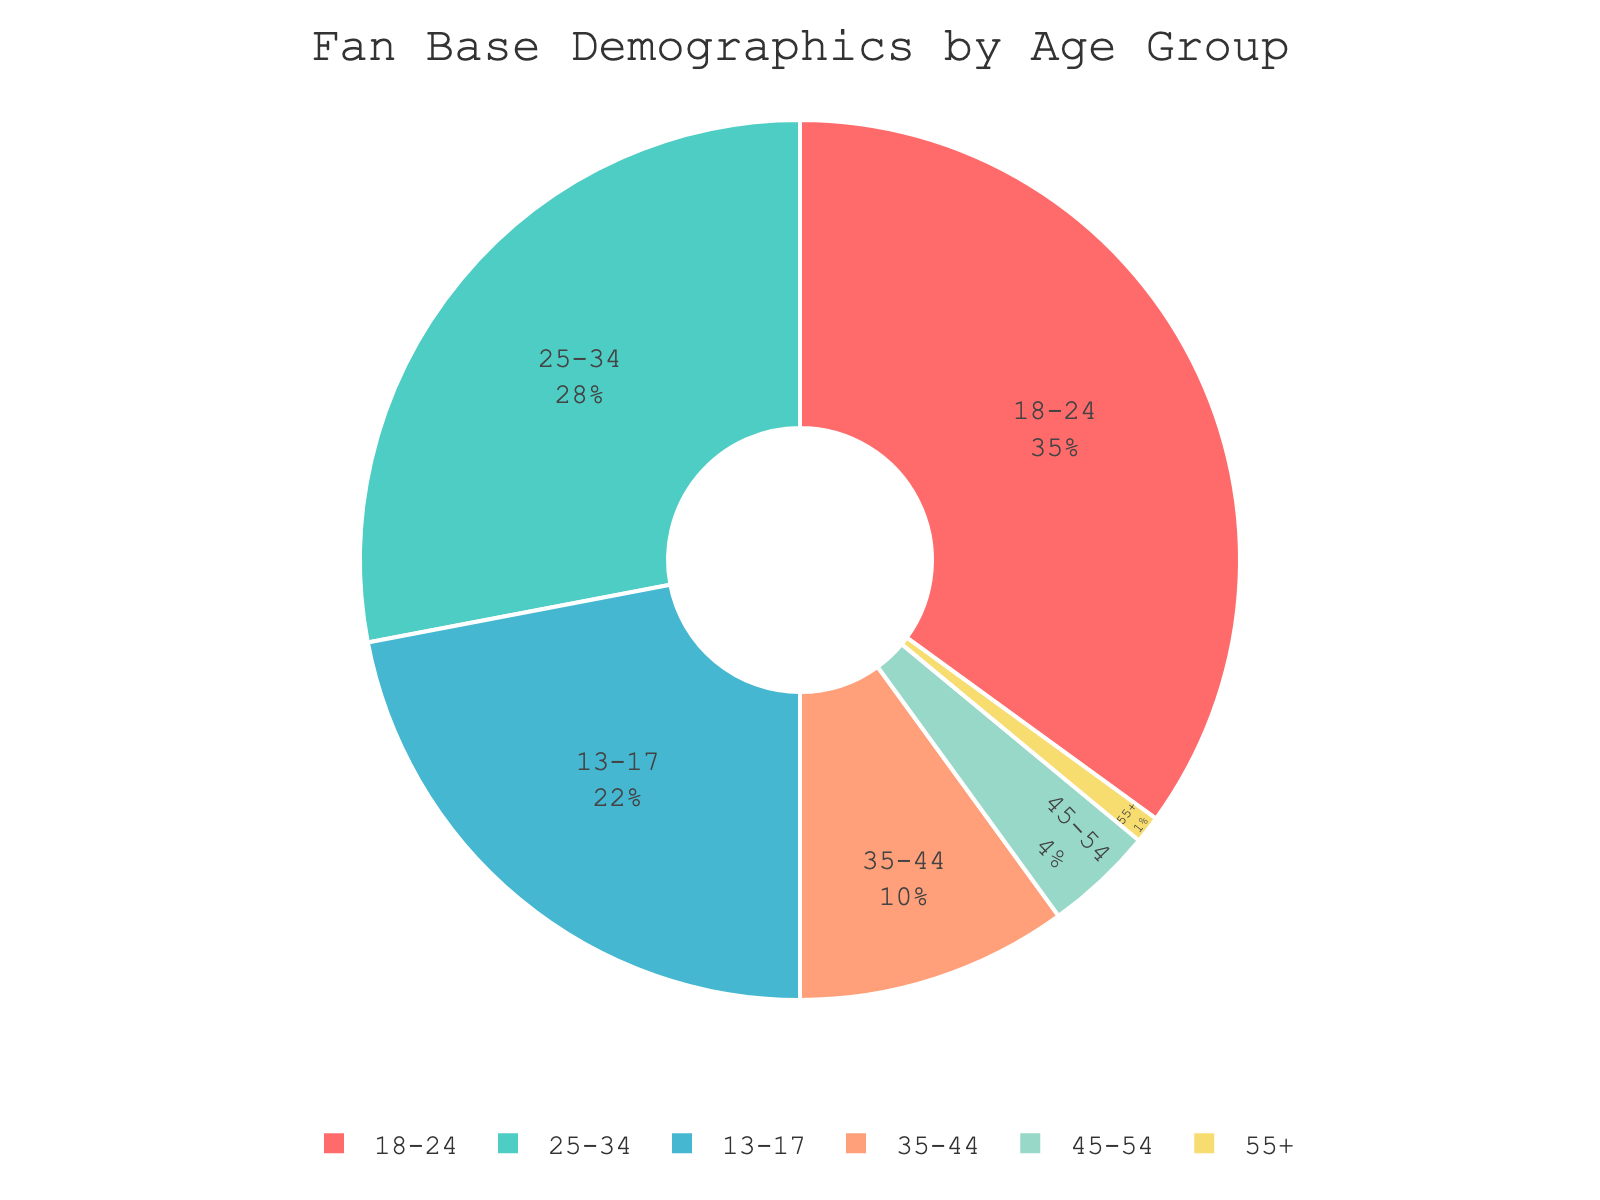What is the largest age group in the fan base? The largest age group can be identified by looking at the segment with the highest percentage. The "18-24" age group has the largest segment with 35%, making it the largest age group.
Answer: 18-24 Which age group has the smallest representation in the fan base? To find the smallest age group, identify the segment with the lowest percentage. The "55+" age group has the smallest segment with 1%, making it the least represented.
Answer: 55+ What is the combined percentage of fans aged 25-34 and 35-44? To find the combined percentage, sum the percentages of these two age groups: 28% (25-34) + 10% (35-44) = 38%.
Answer: 38% How much larger is the "18-24" age group compared to the "13-17" age group? Subtract the percentage of the "13-17" age group from that of the "18-24" age group: 35% (18-24) - 22% (13-17) = 13%.
Answer: 13% Which age groups combined do not exceed the percentage of the "18-24" age group? Add the percentages of different combinations until finding one that is 35% or less. The combination of "45-54" (4%), "55+" (1%), and "35-44" (10%) totals 15%, which does not exceed 35%. Other combinations of small groups are not strictly needed as this one does suffice.
Answer: 45-54, 55+, 35-44 What percentage of the fan base is younger than 25 years old? Sum the percentages of the "13-17" and "18-24" age groups: 22% (13-17) + 35% (18-24) = 57%.
Answer: 57% Which age group has a representation closest to 10%? Identify the age group with a percentage closest to 10%. The "35-44" age group has exactly 10%, so it is the closest.
Answer: 35-44 Is the percentage of fans aged 25-34 greater than the combined percentage of fans aged 45 and above? Compare the percentage of the "25-34" age group (28%) with the sum of percentages of fans aged 45 and above: 4% (45-54) + 1% (55+) = 5%. Since 28% > 5%, the "25-34" group is larger.
Answer: Yes What is the difference in percentage between the sum of fans aged 35-44 and younger and those aged 45 and older? Sum the percentages of fans aged 35-44 and younger: 22% (13-17) + 35% (18-24) + 28% (25-34) + 10% (35-44) = 95%. Sum the percentages of fans aged 45 and older: 4% (45-54) + 1% (55+) = 5%. The difference is 95% - 5% = 90%.
Answer: 90% 